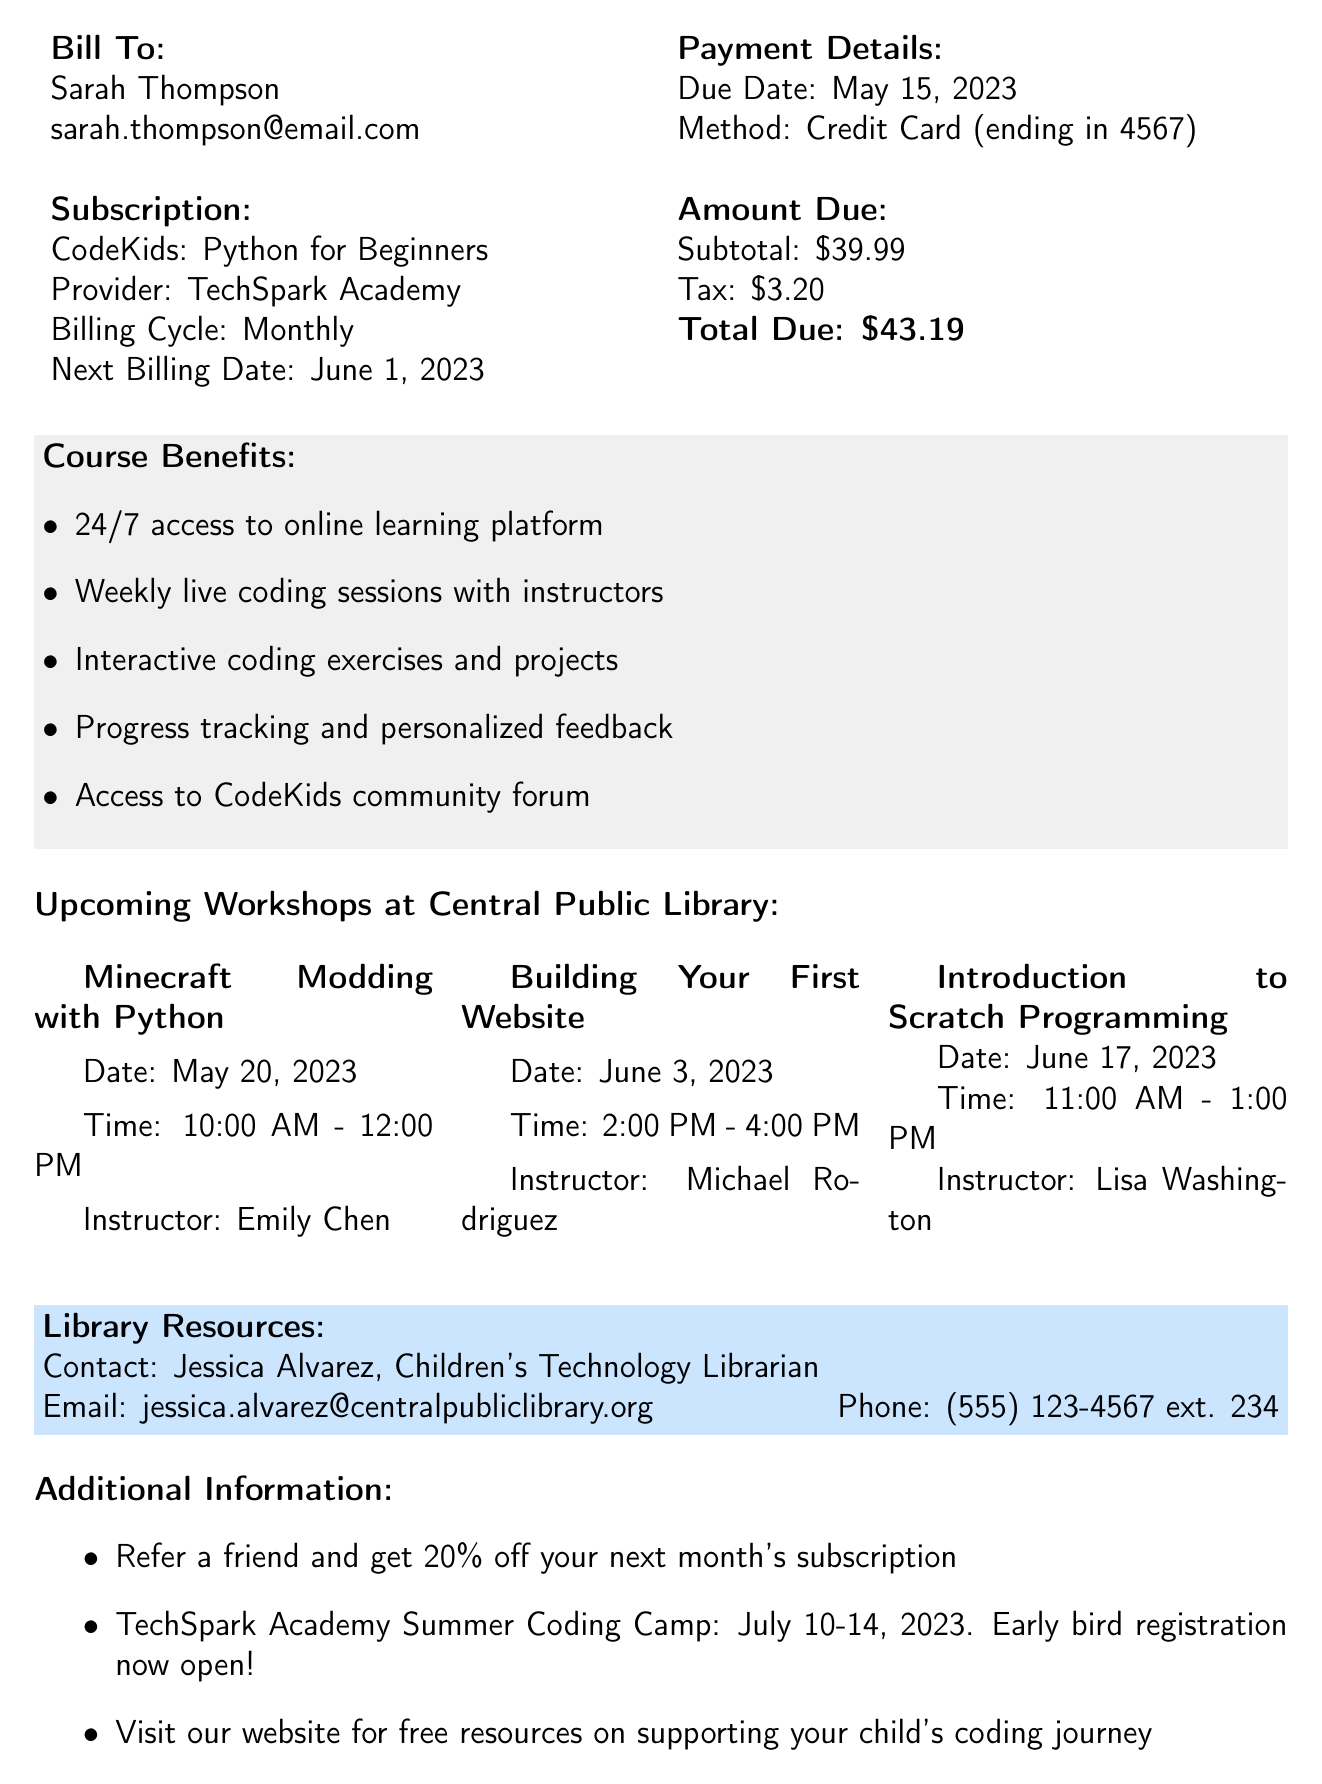What is the invoice number? The invoice number can be found in the invoice details section of the document.
Answer: INV-2023-05-001 What is the monthly fee for the coding course? The monthly fee is mentioned in the subscription information section.
Answer: 39.99 When is the due date for the invoice? The due date is stated in the invoice details section.
Answer: May 15, 2023 What is the name of the course? The course name is specified in the subscription information section.
Answer: CodeKids: Python for Beginners What is the total amount due? The total amount due is listed in the payment details section.
Answer: 43.19 How many upcoming workshops are listed? The number of upcoming workshops can be counted in the upcoming workshops section.
Answer: 3 Who is the instructor for the "Minecraft Modding with Python" workshop? The instructor's name is provided along with the workshop details.
Answer: Emily Chen What is the date of the "Building Your First Website" workshop? The date of the workshop is found in the upcoming workshops section.
Answer: June 3, 2023 What benefit provides 24/7 access to learning? The benefits are listed under the course benefits section.
Answer: 24/7 access to online learning platform 